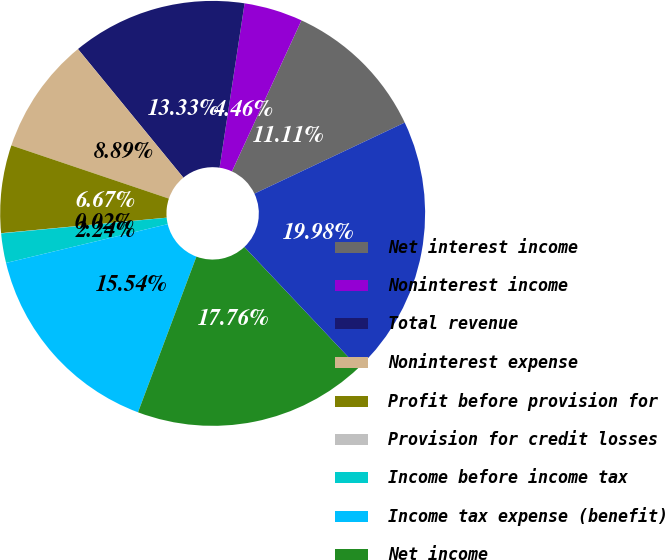Convert chart to OTSL. <chart><loc_0><loc_0><loc_500><loc_500><pie_chart><fcel>Net interest income<fcel>Noninterest income<fcel>Total revenue<fcel>Noninterest expense<fcel>Profit before provision for<fcel>Provision for credit losses<fcel>Income before income tax<fcel>Income tax expense (benefit)<fcel>Net income<fcel>Loans and leases and loans<nl><fcel>11.11%<fcel>4.46%<fcel>13.33%<fcel>8.89%<fcel>6.67%<fcel>0.02%<fcel>2.24%<fcel>15.54%<fcel>17.76%<fcel>19.98%<nl></chart> 